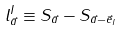Convert formula to latex. <formula><loc_0><loc_0><loc_500><loc_500>l ^ { I } _ { \vec { a } } \equiv S _ { \vec { a } } - S _ { \vec { a } - \vec { e } _ { I } }</formula> 